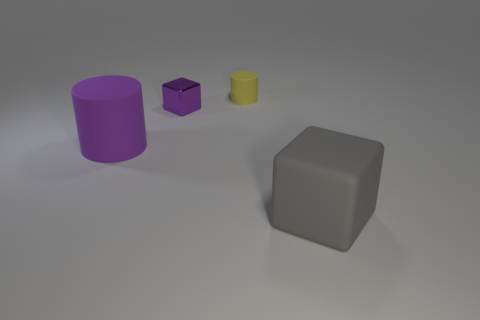Add 3 cyan spheres. How many objects exist? 7 Subtract all yellow cylinders. How many cylinders are left? 1 Subtract 2 cylinders. How many cylinders are left? 0 Subtract all green shiny objects. Subtract all big blocks. How many objects are left? 3 Add 4 gray rubber cubes. How many gray rubber cubes are left? 5 Add 1 small red metal cylinders. How many small red metal cylinders exist? 1 Subtract 0 cyan cylinders. How many objects are left? 4 Subtract all yellow cubes. Subtract all green cylinders. How many cubes are left? 2 